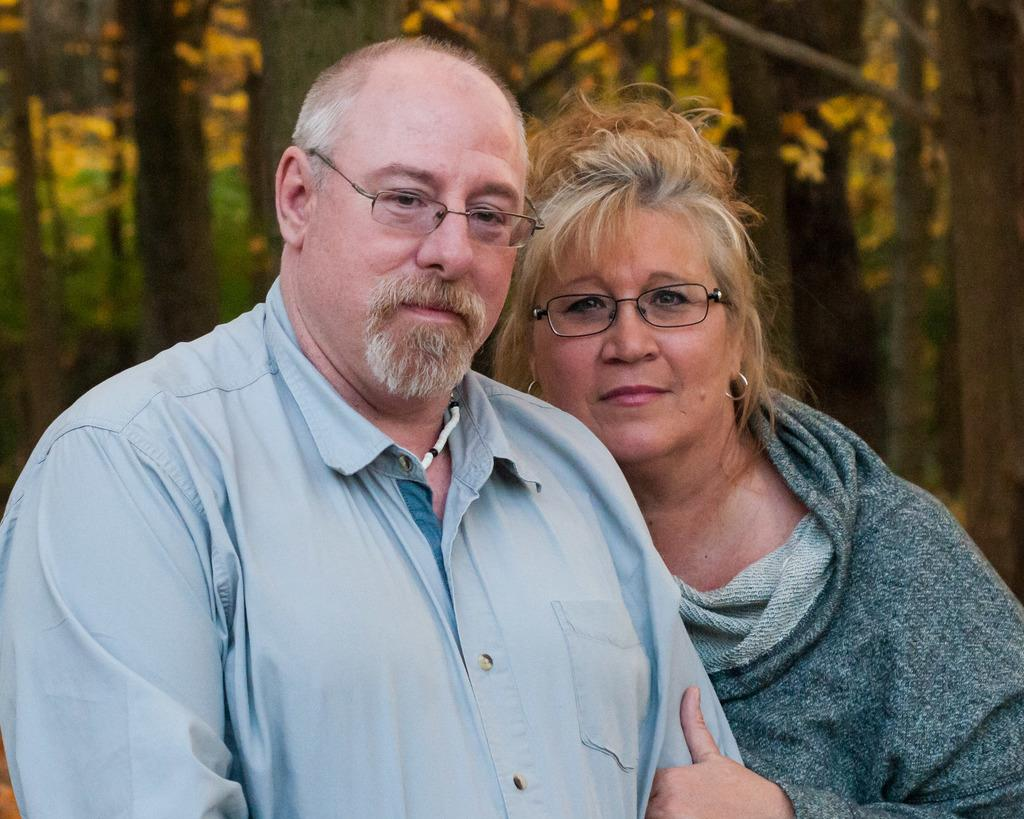What is the main subject in the foreground of the image? There is a man and a woman in the foreground of the image. What is the man wearing in the image? The man is wearing a blue shirt in the image. What is the woman wearing in the image? The woman is wearing a grey T-shirt in the image. What can be seen in the background of the image? There are trees in the background of the image. What type of food is the man eating in the image? There is no food visible in the image, and the man is not shown eating anything. 